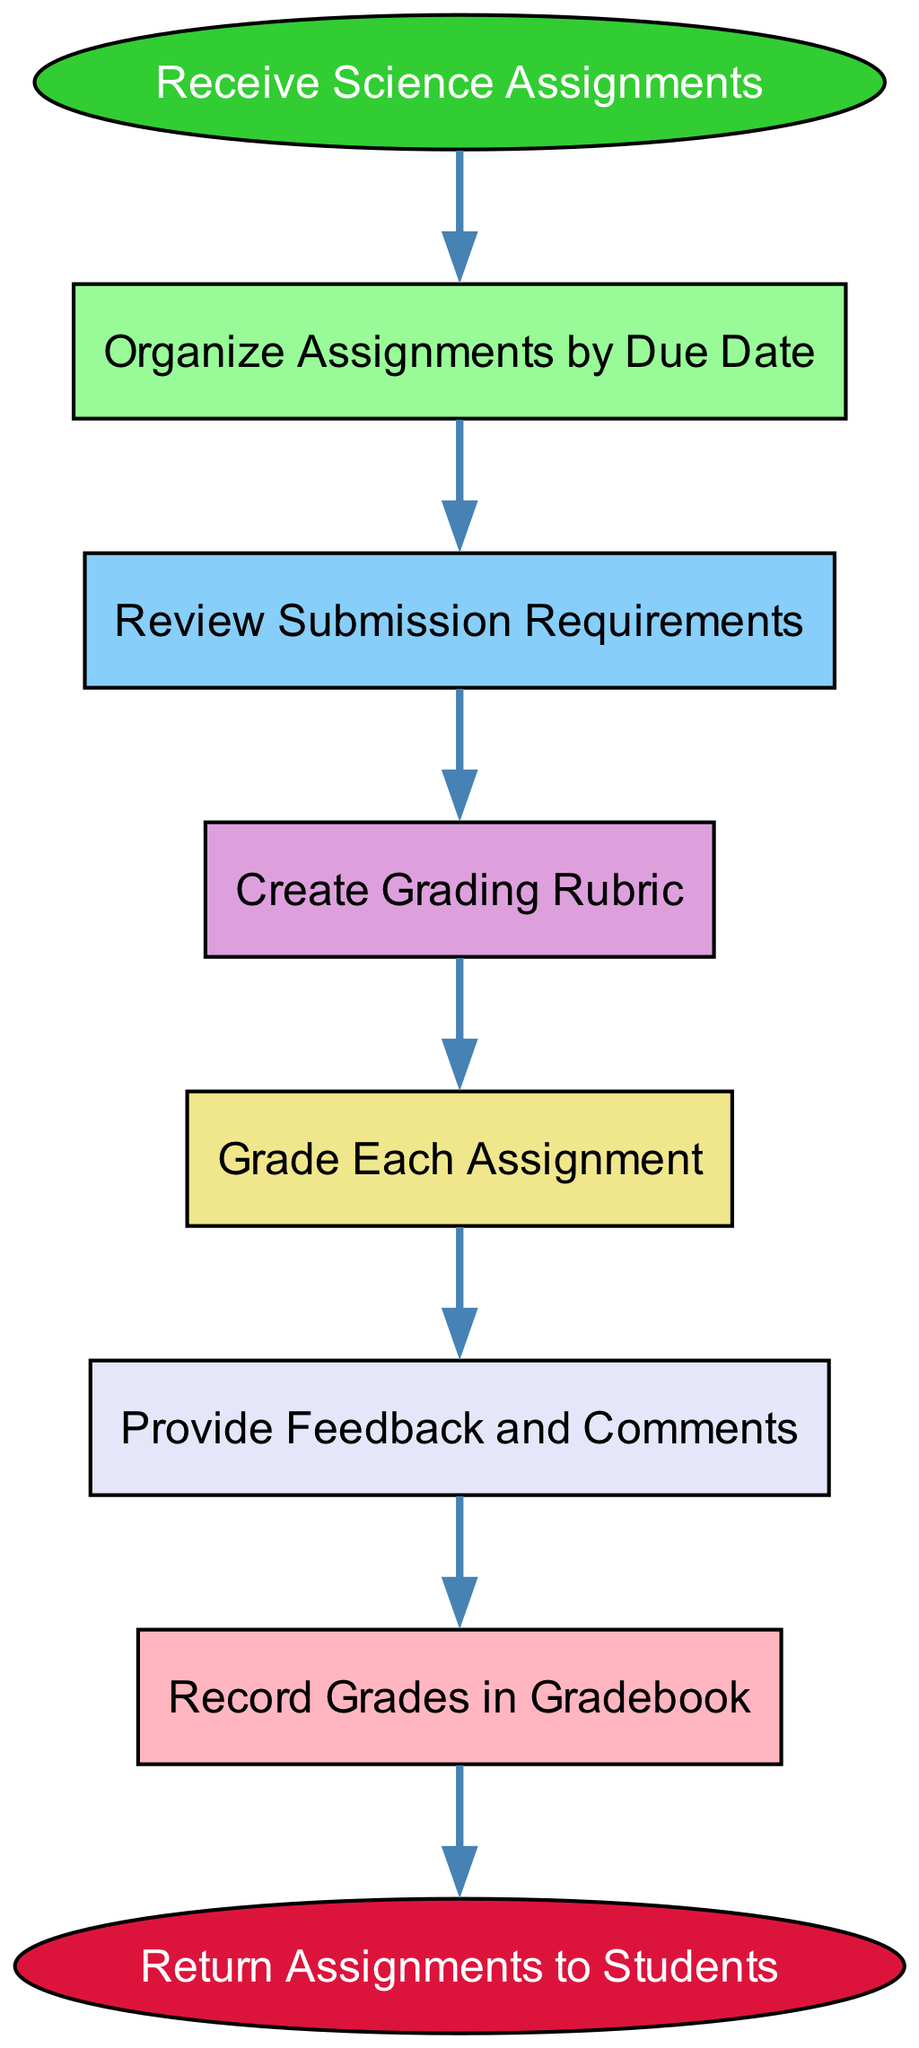What is the first step in the workflow? The workflow begins with the node labeled "Receive Science Assignments," which indicates the initial action taken once assignments are available.
Answer: Receive Science Assignments How many nodes are in the diagram? There are eight nodes representing different steps in the workflow, as indicated by the elements listed in the data provided.
Answer: Eight What color represents the end of the workflow? The end of the workflow is represented by a red ellipse, specifically the node labeled "Return Assignments to Students."
Answer: Red What step comes immediately after "Create Grading Rubric"? The step that follows "Create Grading Rubric" is "Grade Each Assignment," which shows the sequence of actions taken in the grading process.
Answer: Grade Each Assignment Which step involves communication to the students? The step that includes feedback to the students is "Provide Feedback and Comments," as this involves sharing insights on their submissions.
Answer: Provide Feedback and Comments Explain the relationship between "Organize Assignments by Due Date" and "Review Submission Requirements." After receiving the assignments, they are organized by their due date, which helps in managing them effectively before reviewing each submission's specific requirements. This shows the logical flow of preparation before grading.
Answer: Organize Assignments by Due Date leads to Review Submission Requirements What is the last action taken in this grading workflow? The final action, which signifies the conclusion of the workflow, is denoted by the node "Return Assignments to Students," indicating that feedback and grades are finalized and returned.
Answer: Return Assignments to Students Which step comes before "Record Grades in Gradebook"? The step preceding "Record Grades in Gradebook" is "Provide Feedback and Comments," signifying that grades are first prepared with feedback before officially being recorded.
Answer: Provide Feedback and Comments How is the grading process structured in relation to feedback? The grading process involves grading each assignment, which is followed by providing feedback and comments, emphasizing that feedback is an integral part of the grading procedure.
Answer: Grade Each Assignment then Provide Feedback and Comments 